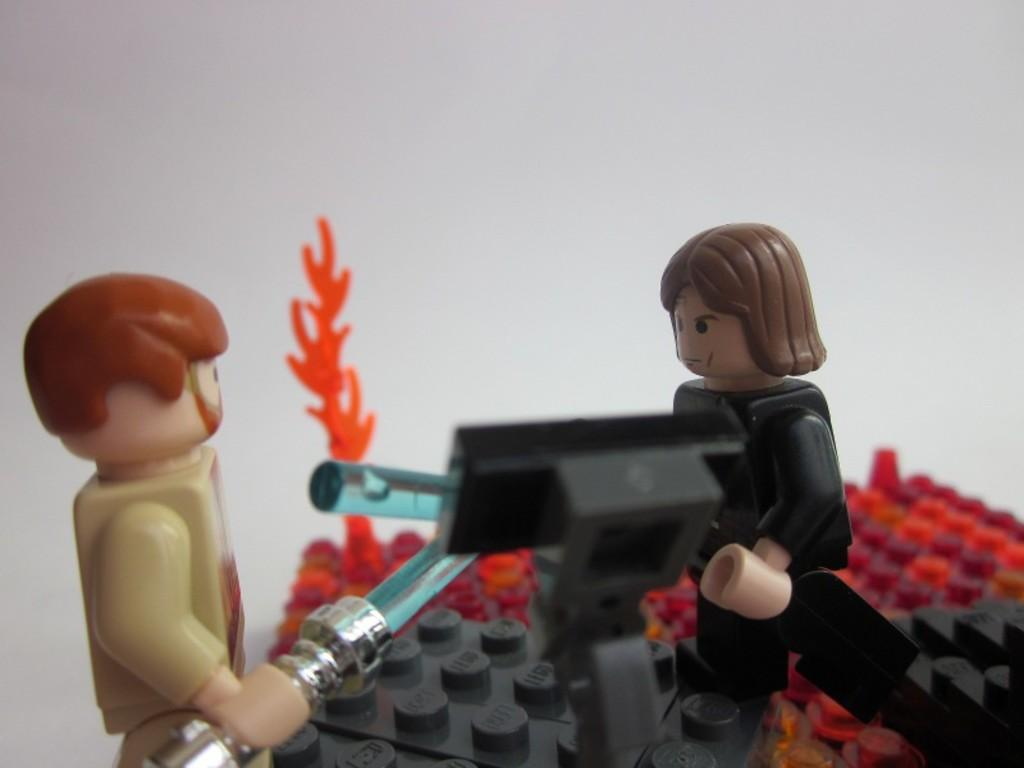What is located in the center of the image? There are toys in the center of the image. Can you describe the specific type of toys at the bottom of the image? There are Lego toys at the bottom of the image. What can be seen in the background of the image? There is a wall in the background of the image. What type of voice can be heard coming from the toys in the image? There is no voice present in the image, as it features toys and not living beings capable of producing sound. 